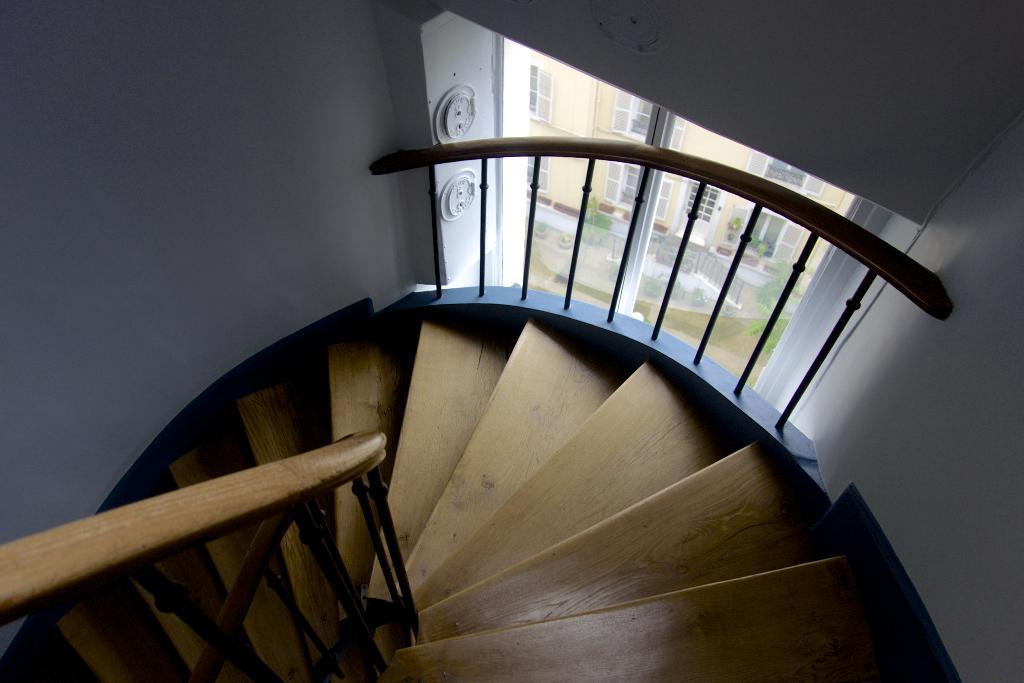What type of architectural feature is present in the image? There is a staircase in the image. What is located near the staircase? There is a fencing to the side of the staircase. What can be seen through the window in the image? A house is visible through the window. Can you describe the window's position in relation to the staircase? The window is located near the staircase. What type of insurance policy is being discussed in the meeting visible through the window? There is no meeting visible through the window, nor is there any mention of an insurance policy in the image. 